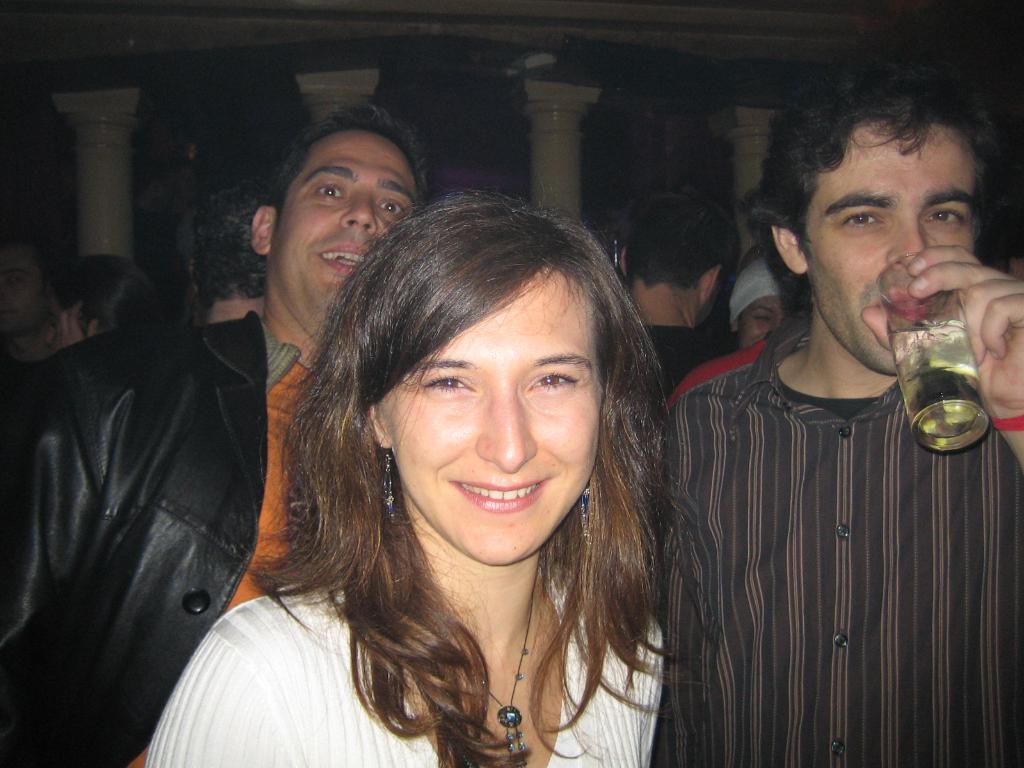How many people are present in the image? There are three persons in the image. What is one of the persons holding? One of the persons is holding a glass. Can you describe the background of the image? There are people and pillars in the background of the image. What type of goldfish can be seen swimming in the glass held by one of the persons in the image? There is no goldfish present in the image; one of the persons is holding a glass, but it is not specified what is inside the glass. 